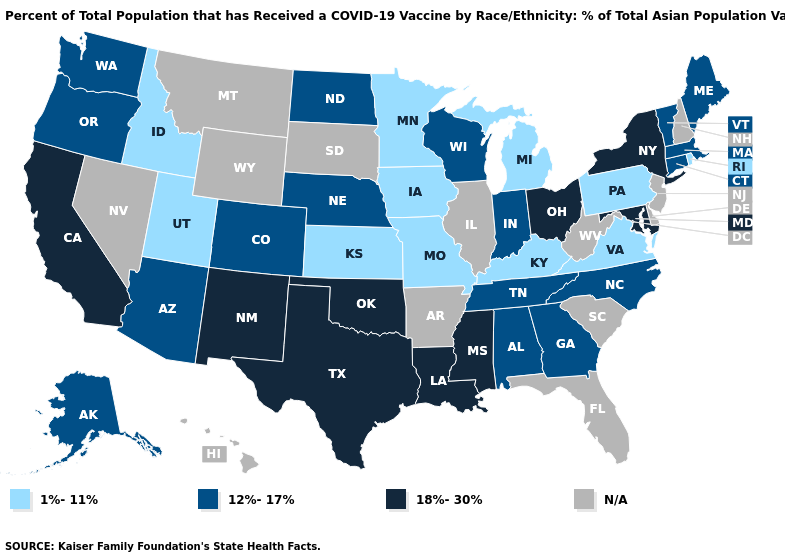What is the value of Vermont?
Answer briefly. 12%-17%. Name the states that have a value in the range 12%-17%?
Be succinct. Alabama, Alaska, Arizona, Colorado, Connecticut, Georgia, Indiana, Maine, Massachusetts, Nebraska, North Carolina, North Dakota, Oregon, Tennessee, Vermont, Washington, Wisconsin. Name the states that have a value in the range 12%-17%?
Short answer required. Alabama, Alaska, Arizona, Colorado, Connecticut, Georgia, Indiana, Maine, Massachusetts, Nebraska, North Carolina, North Dakota, Oregon, Tennessee, Vermont, Washington, Wisconsin. Which states have the lowest value in the USA?
Give a very brief answer. Idaho, Iowa, Kansas, Kentucky, Michigan, Minnesota, Missouri, Pennsylvania, Rhode Island, Utah, Virginia. Which states hav the highest value in the Northeast?
Write a very short answer. New York. What is the value of Maine?
Quick response, please. 12%-17%. Name the states that have a value in the range 18%-30%?
Write a very short answer. California, Louisiana, Maryland, Mississippi, New Mexico, New York, Ohio, Oklahoma, Texas. What is the value of Texas?
Concise answer only. 18%-30%. What is the highest value in states that border Oregon?
Be succinct. 18%-30%. Which states hav the highest value in the South?
Answer briefly. Louisiana, Maryland, Mississippi, Oklahoma, Texas. Name the states that have a value in the range 1%-11%?
Concise answer only. Idaho, Iowa, Kansas, Kentucky, Michigan, Minnesota, Missouri, Pennsylvania, Rhode Island, Utah, Virginia. Does the first symbol in the legend represent the smallest category?
Write a very short answer. Yes. How many symbols are there in the legend?
Give a very brief answer. 4. 